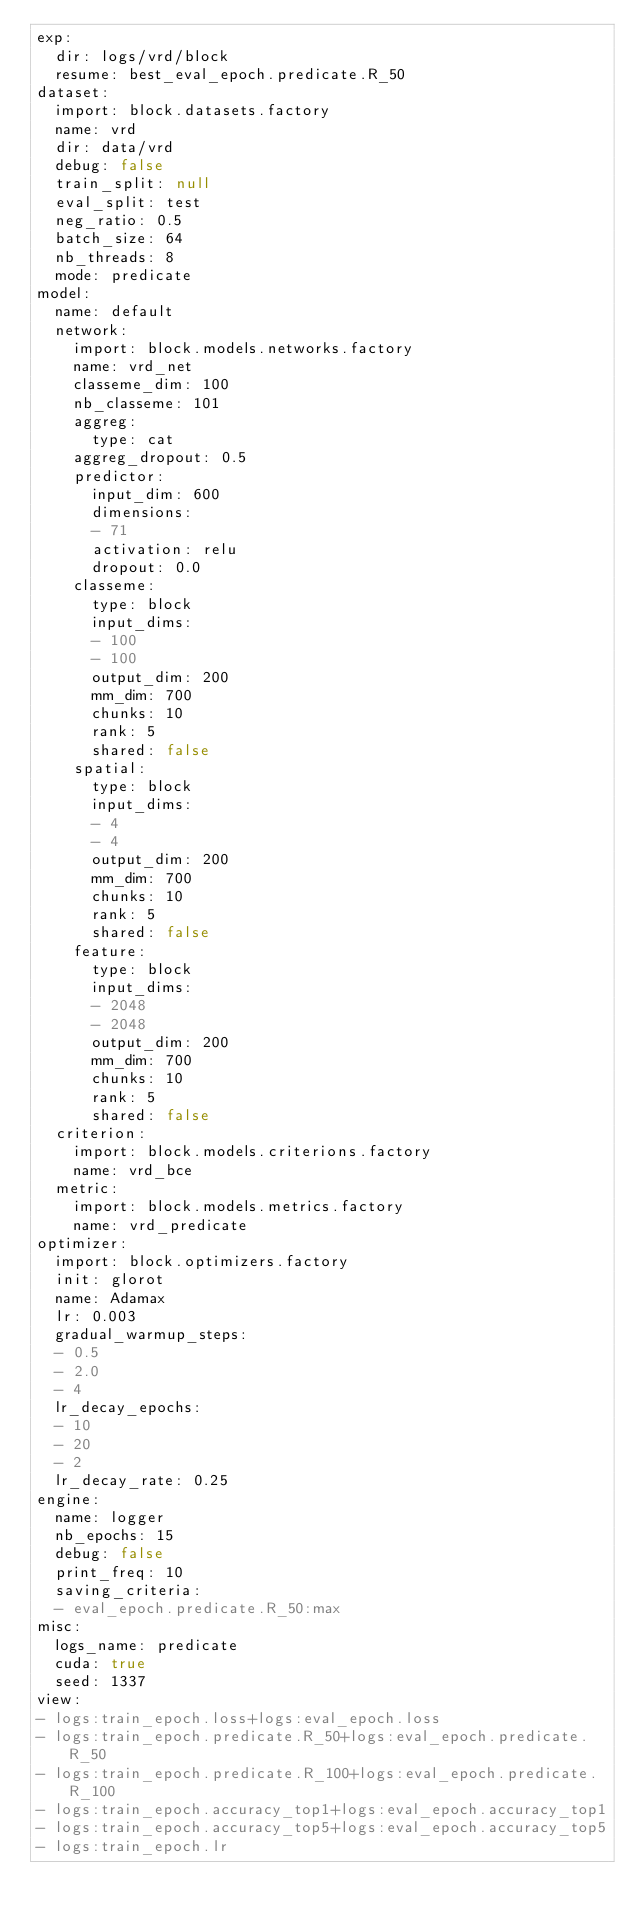Convert code to text. <code><loc_0><loc_0><loc_500><loc_500><_YAML_>exp:
  dir: logs/vrd/block
  resume: best_eval_epoch.predicate.R_50
dataset:
  import: block.datasets.factory
  name: vrd
  dir: data/vrd
  debug: false
  train_split: null
  eval_split: test
  neg_ratio: 0.5
  batch_size: 64
  nb_threads: 8
  mode: predicate
model:
  name: default
  network:
    import: block.models.networks.factory
    name: vrd_net
    classeme_dim: 100
    nb_classeme: 101
    aggreg:
      type: cat
    aggreg_dropout: 0.5
    predictor:
      input_dim: 600
      dimensions:
      - 71
      activation: relu
      dropout: 0.0
    classeme:
      type: block
      input_dims:
      - 100
      - 100
      output_dim: 200
      mm_dim: 700
      chunks: 10
      rank: 5
      shared: false
    spatial:
      type: block
      input_dims:
      - 4
      - 4
      output_dim: 200
      mm_dim: 700
      chunks: 10
      rank: 5
      shared: false
    feature:
      type: block
      input_dims:
      - 2048
      - 2048
      output_dim: 200
      mm_dim: 700
      chunks: 10
      rank: 5
      shared: false
  criterion:
    import: block.models.criterions.factory
    name: vrd_bce
  metric:
    import: block.models.metrics.factory
    name: vrd_predicate
optimizer:
  import: block.optimizers.factory
  init: glorot
  name: Adamax
  lr: 0.003
  gradual_warmup_steps:
  - 0.5
  - 2.0
  - 4
  lr_decay_epochs:
  - 10
  - 20
  - 2
  lr_decay_rate: 0.25
engine:
  name: logger
  nb_epochs: 15
  debug: false
  print_freq: 10
  saving_criteria:
  - eval_epoch.predicate.R_50:max
misc:
  logs_name: predicate
  cuda: true
  seed: 1337
view:
- logs:train_epoch.loss+logs:eval_epoch.loss
- logs:train_epoch.predicate.R_50+logs:eval_epoch.predicate.R_50
- logs:train_epoch.predicate.R_100+logs:eval_epoch.predicate.R_100
- logs:train_epoch.accuracy_top1+logs:eval_epoch.accuracy_top1
- logs:train_epoch.accuracy_top5+logs:eval_epoch.accuracy_top5
- logs:train_epoch.lr
</code> 